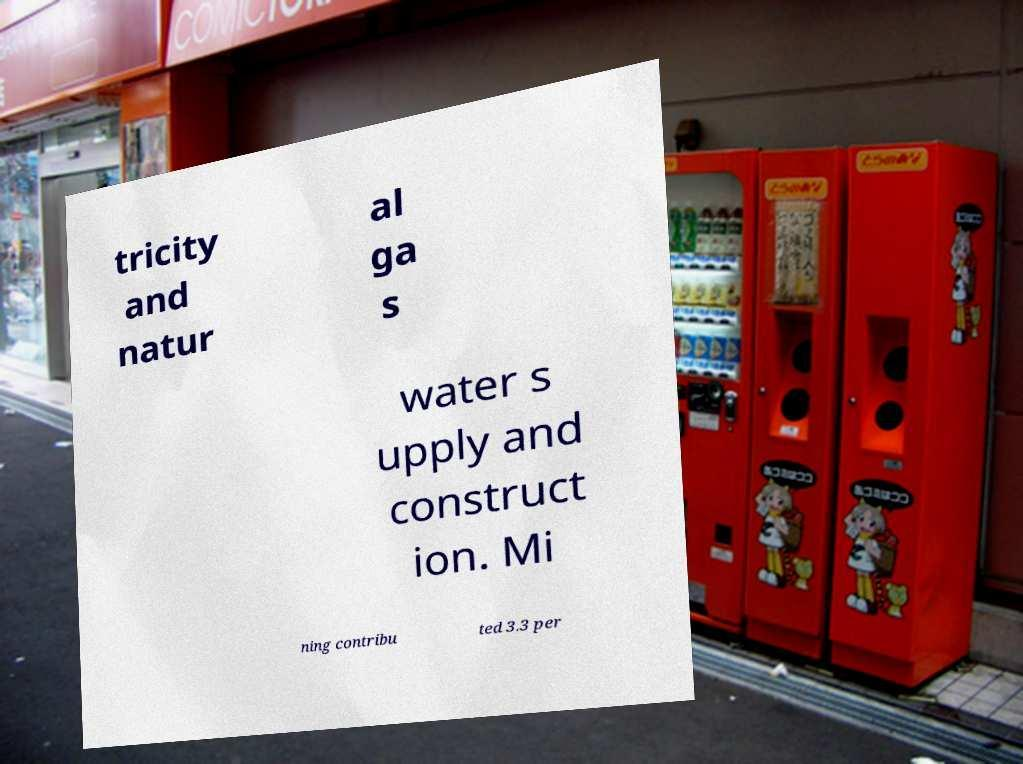Can you read and provide the text displayed in the image?This photo seems to have some interesting text. Can you extract and type it out for me? tricity and natur al ga s water s upply and construct ion. Mi ning contribu ted 3.3 per 